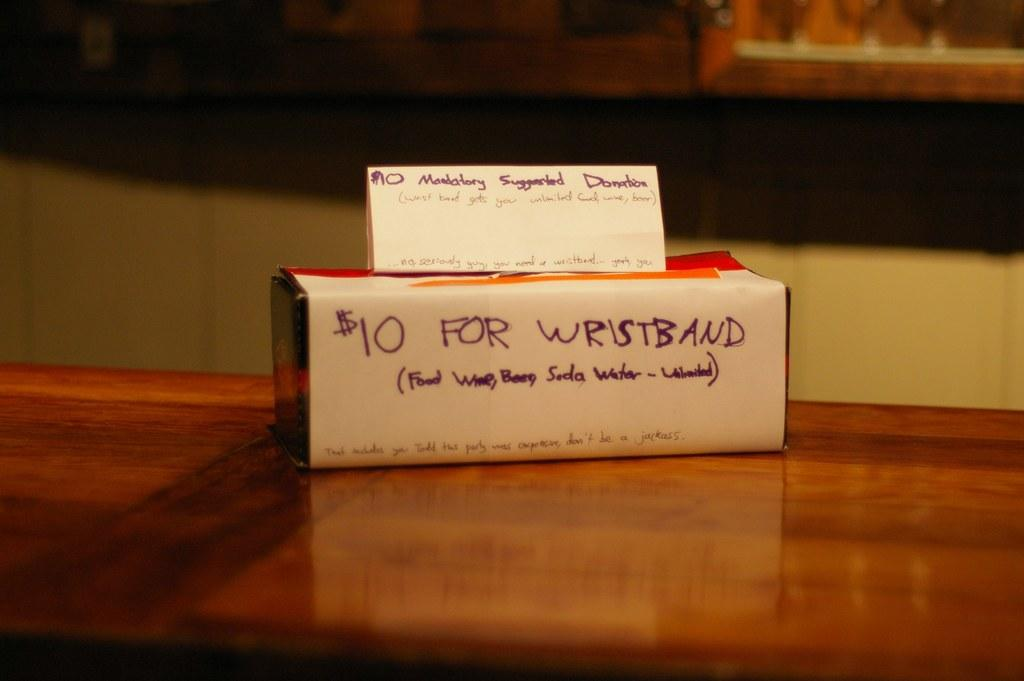<image>
Present a compact description of the photo's key features. A $10 mandatory suggestion Donation sign sits above another sign for $10 wristbands 